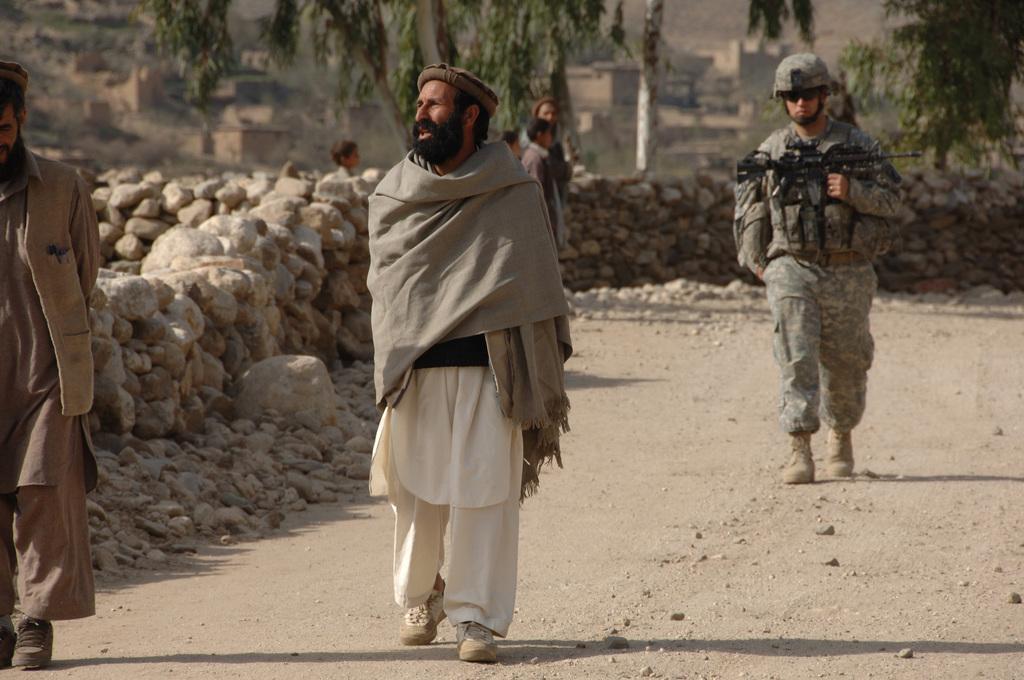How would you summarize this image in a sentence or two? In this image we can see there are few people are walking on the road, beside the road there are some rocks. In the background there are some trees and buildings. 